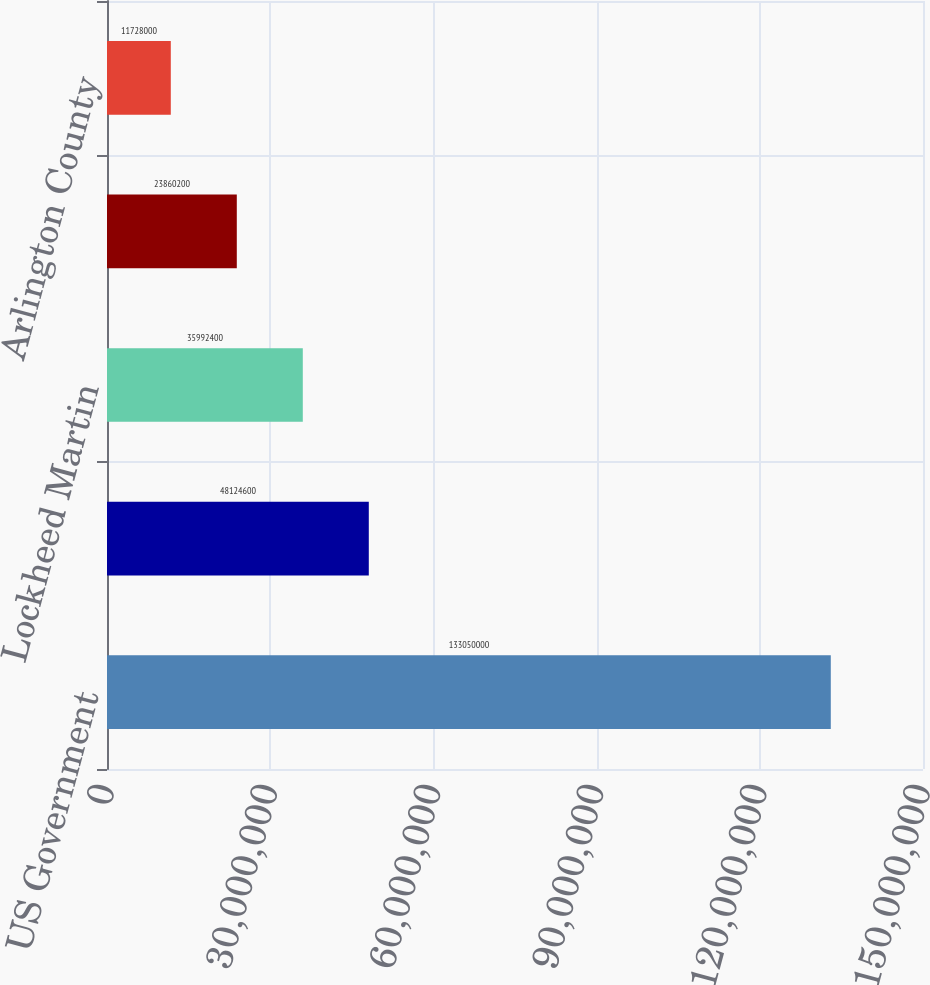Convert chart to OTSL. <chart><loc_0><loc_0><loc_500><loc_500><bar_chart><fcel>US Government<fcel>Boeing<fcel>Lockheed Martin<fcel>Family Health International<fcel>Arlington County<nl><fcel>1.3305e+08<fcel>4.81246e+07<fcel>3.59924e+07<fcel>2.38602e+07<fcel>1.1728e+07<nl></chart> 